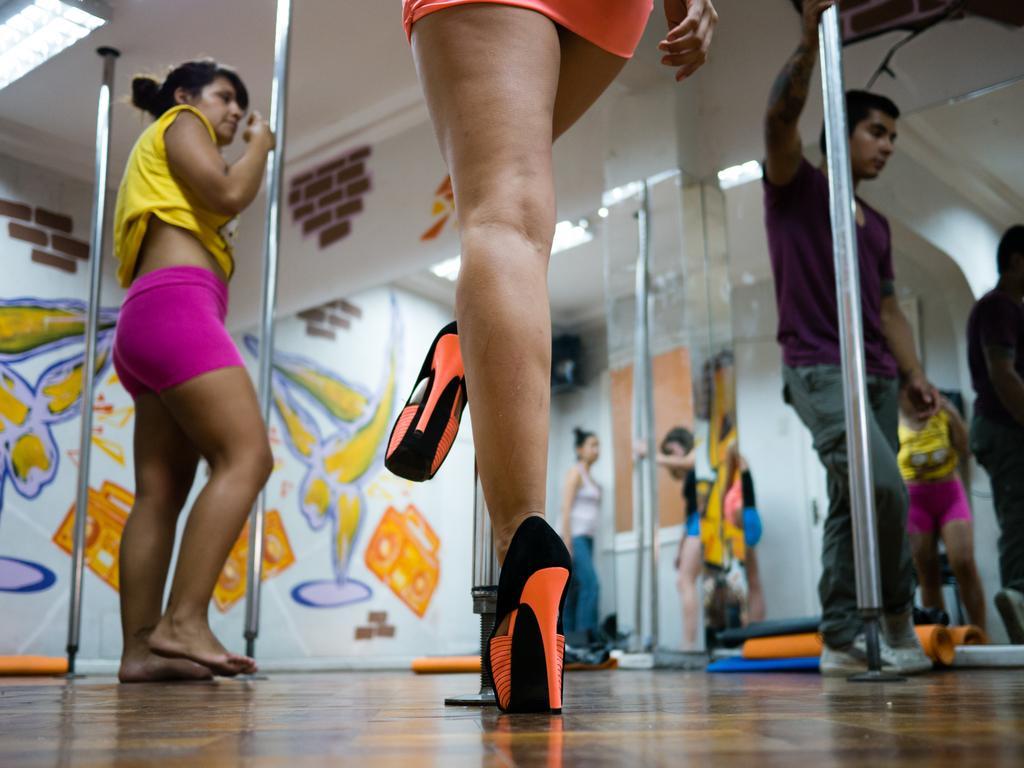Could you give a brief overview of what you see in this image? In the picture I can see the legs of a woman in the middle of the image. I can see a woman on the left side. There is a man on the right side holding the stainless steel pole. In the background, I can see the painting on the wall. 